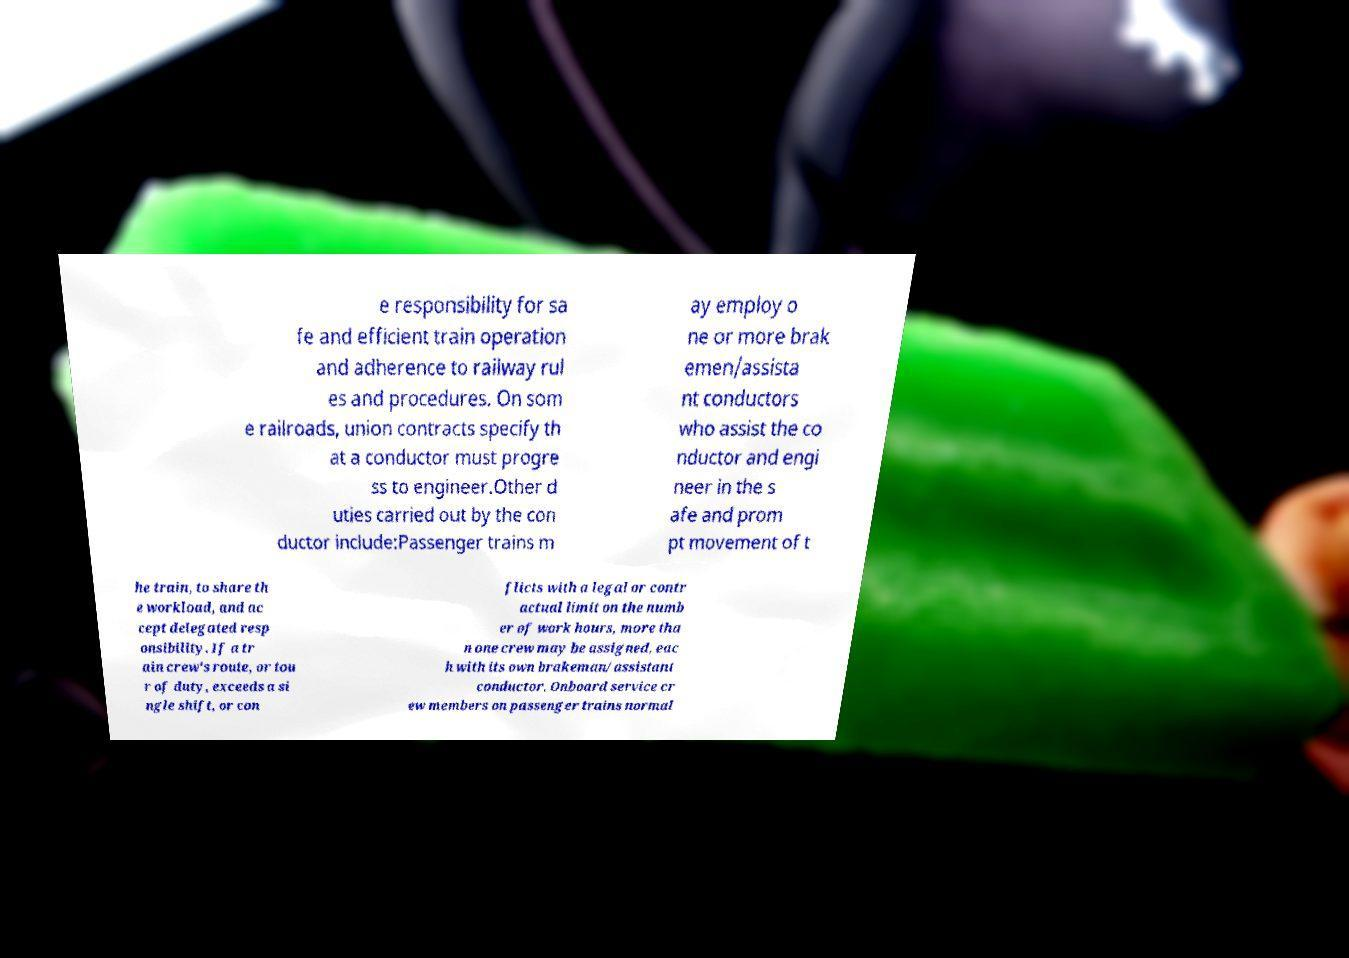Please identify and transcribe the text found in this image. e responsibility for sa fe and efficient train operation and adherence to railway rul es and procedures. On som e railroads, union contracts specify th at a conductor must progre ss to engineer.Other d uties carried out by the con ductor include:Passenger trains m ay employ o ne or more brak emen/assista nt conductors who assist the co nductor and engi neer in the s afe and prom pt movement of t he train, to share th e workload, and ac cept delegated resp onsibility. If a tr ain crew's route, or tou r of duty, exceeds a si ngle shift, or con flicts with a legal or contr actual limit on the numb er of work hours, more tha n one crew may be assigned, eac h with its own brakeman/assistant conductor. Onboard service cr ew members on passenger trains normal 